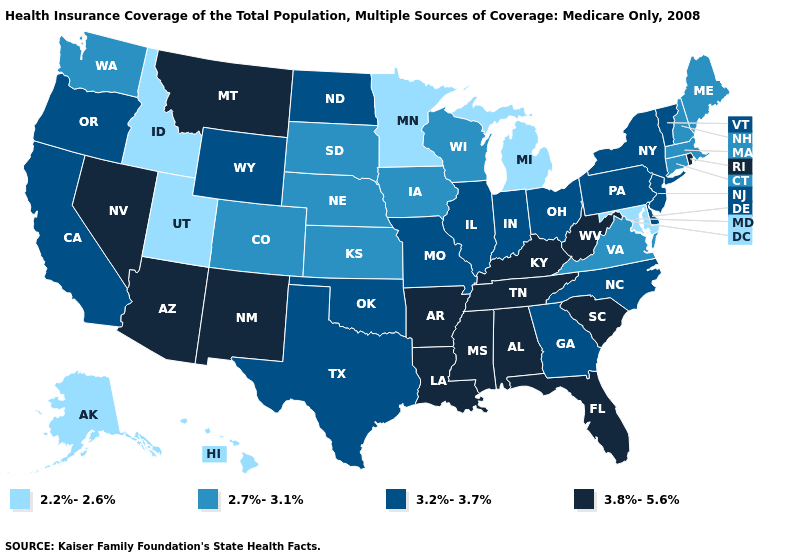Name the states that have a value in the range 2.7%-3.1%?
Answer briefly. Colorado, Connecticut, Iowa, Kansas, Maine, Massachusetts, Nebraska, New Hampshire, South Dakota, Virginia, Washington, Wisconsin. What is the value of North Carolina?
Be succinct. 3.2%-3.7%. Among the states that border Nebraska , does Kansas have the highest value?
Concise answer only. No. Does New Mexico have the highest value in the USA?
Quick response, please. Yes. Among the states that border Minnesota , does South Dakota have the highest value?
Quick response, please. No. Name the states that have a value in the range 2.2%-2.6%?
Be succinct. Alaska, Hawaii, Idaho, Maryland, Michigan, Minnesota, Utah. Name the states that have a value in the range 2.7%-3.1%?
Give a very brief answer. Colorado, Connecticut, Iowa, Kansas, Maine, Massachusetts, Nebraska, New Hampshire, South Dakota, Virginia, Washington, Wisconsin. Does Maryland have the lowest value in the South?
Quick response, please. Yes. Name the states that have a value in the range 3.8%-5.6%?
Concise answer only. Alabama, Arizona, Arkansas, Florida, Kentucky, Louisiana, Mississippi, Montana, Nevada, New Mexico, Rhode Island, South Carolina, Tennessee, West Virginia. Does the map have missing data?
Answer briefly. No. What is the value of California?
Keep it brief. 3.2%-3.7%. Name the states that have a value in the range 3.2%-3.7%?
Short answer required. California, Delaware, Georgia, Illinois, Indiana, Missouri, New Jersey, New York, North Carolina, North Dakota, Ohio, Oklahoma, Oregon, Pennsylvania, Texas, Vermont, Wyoming. Which states have the lowest value in the MidWest?
Concise answer only. Michigan, Minnesota. What is the value of Kentucky?
Answer briefly. 3.8%-5.6%. What is the value of Colorado?
Concise answer only. 2.7%-3.1%. 